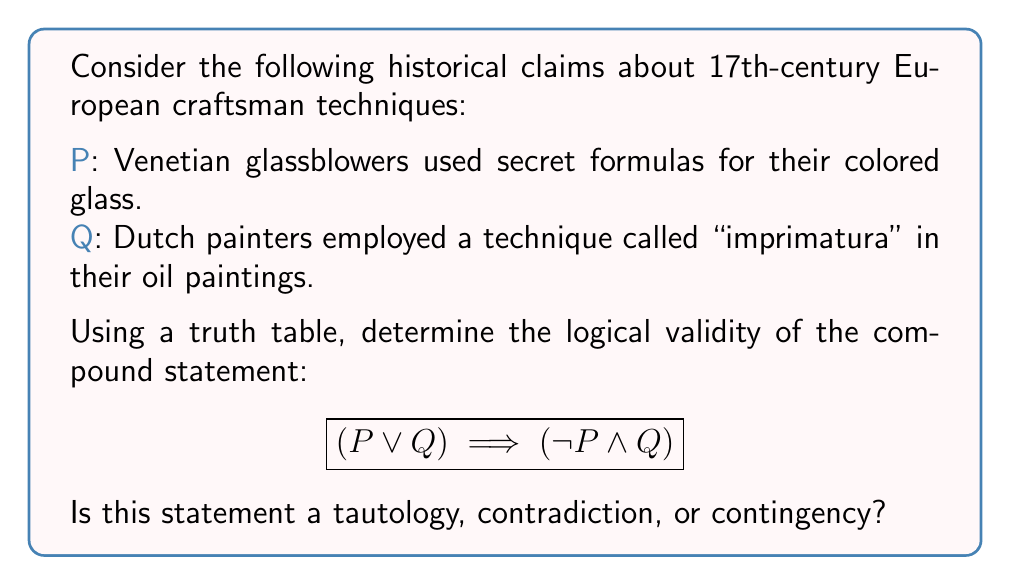Teach me how to tackle this problem. To evaluate the logical validity of the given compound statement, we need to construct a truth table and analyze the results. Let's follow these steps:

1. Identify the atomic propositions: P and Q
2. Construct the truth table with all possible combinations of P and Q
3. Evaluate each component of the compound statement
4. Determine the final result for each row
5. Analyze the results to classify the statement

Step 1: Truth table setup

| P | Q | P ∨ Q | ¬P | ¬P ∧ Q | (P ∨ Q) → (¬P ∧ Q) |
|---|---|-------|----|---------|--------------------|
| T | T |       |    |         |                    |
| T | F |       |    |         |                    |
| F | T |       |    |         |                    |
| F | F |       |    |         |                    |

Step 2: Evaluate P ∨ Q

| P | Q | P ∨ Q | ¬P | ¬P ∧ Q | (P ∨ Q) → (¬P ∧ Q) |
|---|---|-------|----|---------|--------------------|
| T | T |   T   |    |         |                    |
| T | F |   T   |    |         |                    |
| F | T |   T   |    |         |                    |
| F | F |   F   |    |         |                    |

Step 3: Evaluate ¬P

| P | Q | P ∨ Q | ¬P | ¬P ∧ Q | (P ∨ Q) → (¬P ∧ Q) |
|---|---|-------|----|---------|--------------------|
| T | T |   T   | F  |         |                    |
| T | F |   T   | F  |         |                    |
| F | T |   T   | T  |         |                    |
| F | F |   F   | T  |         |                    |

Step 4: Evaluate ¬P ∧ Q

| P | Q | P ∨ Q | ¬P | ¬P ∧ Q | (P ∨ Q) → (¬P ∧ Q) |
|---|---|-------|----|---------|--------------------|
| T | T |   T   | F  |    F    |                    |
| T | F |   T   | F  |    F    |                    |
| F | T |   T   | T  |    T    |                    |
| F | F |   F   | T  |    F    |                    |

Step 5: Evaluate (P ∨ Q) → (¬P ∧ Q)

| P | Q | P ∨ Q | ¬P | ¬P ∧ Q | (P ∨ Q) → (¬P ∧ Q) |
|---|---|-------|----|---------|--------------------|
| T | T |   T   | F  |    F    |         F          |
| T | F |   T   | F  |    F    |         F          |
| F | T |   T   | T  |    T    |         T          |
| F | F |   F   | T  |    F    |         T          |

Step 6: Analyze the results

The compound statement is false when P is true (rows 1 and 2) and true when P is false (rows 3 and 4). Since the statement is not always true and not always false, it is neither a tautology nor a contradiction.

Therefore, the compound statement $$(P \lor Q) \implies (\neg P \land Q)$$ is a contingency.
Answer: Contingency 